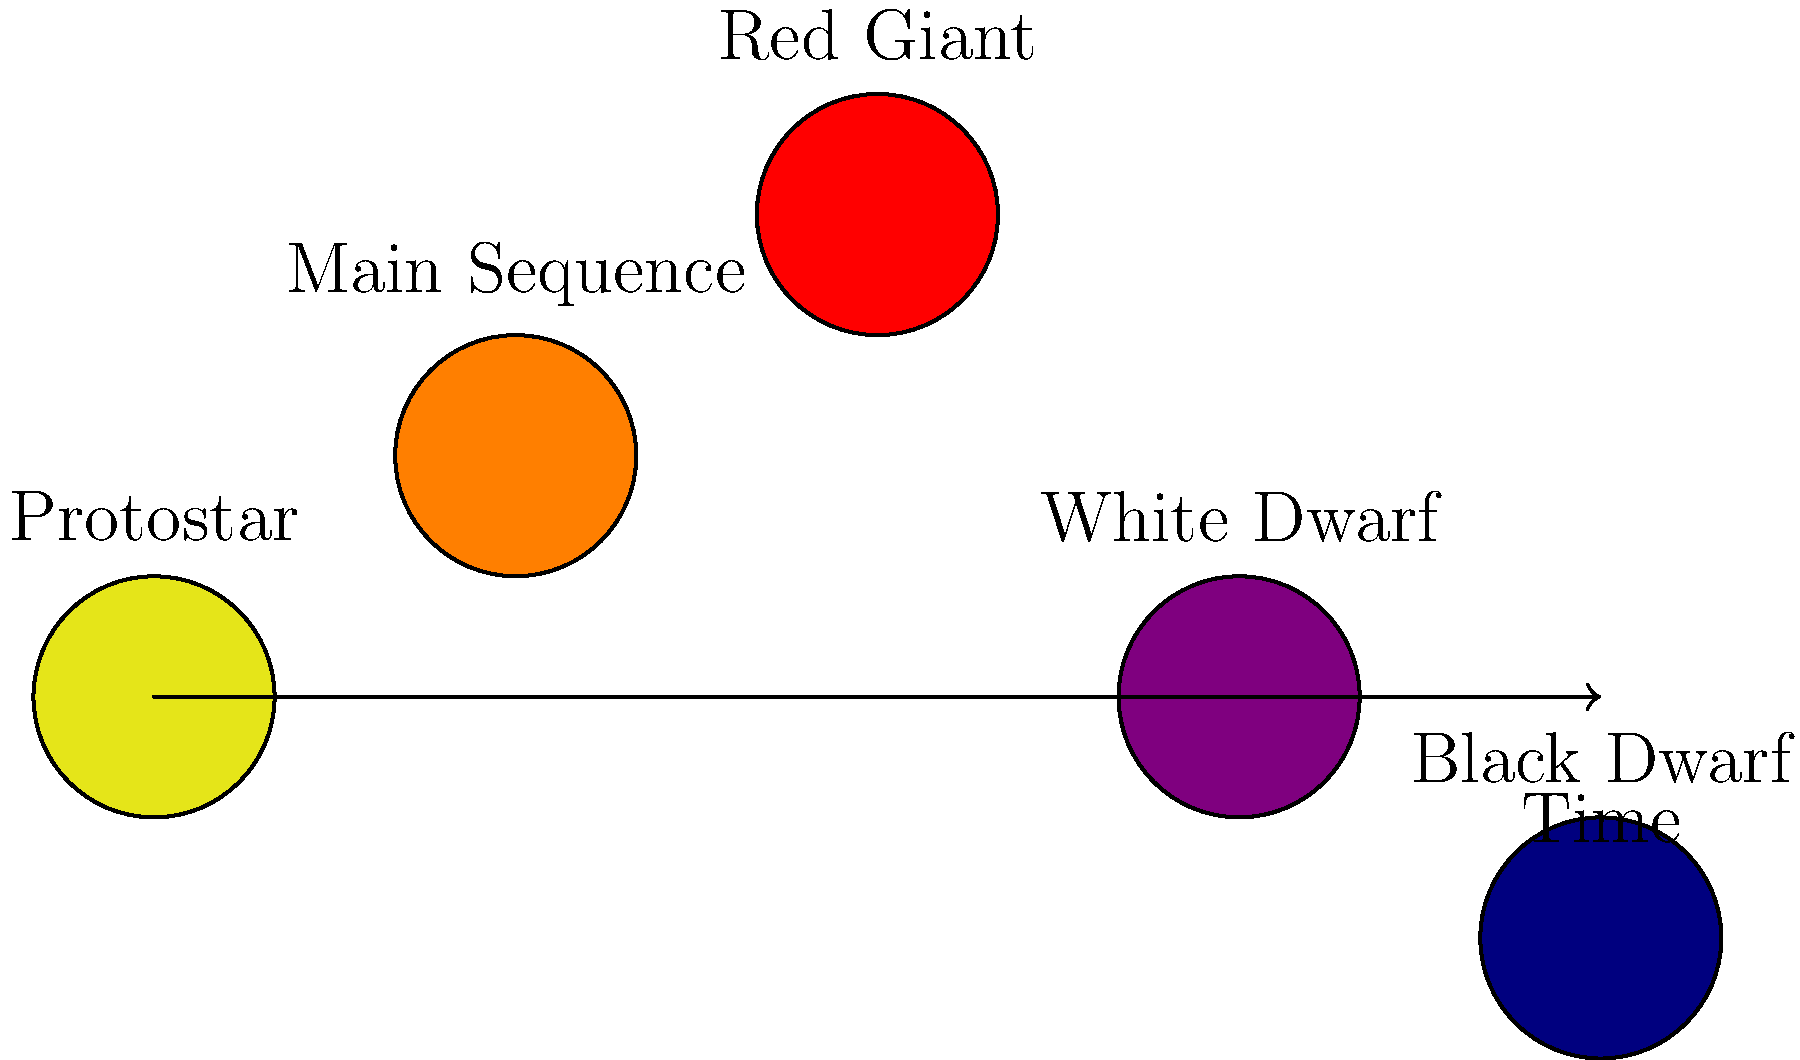As a journalist covering a space science conference, you encounter a diagram depicting the life cycle of a star. Which stage in this cycle represents the longest period in a star's life, and why is this stage crucial for the existence of life as we know it? Let's break down the life cycle of a star and analyze each stage:

1. Protostar: This is the initial stage where a cloud of gas and dust collapses under gravity.

2. Main Sequence: This is the longest stage in a star's life. Here's why it's important:
   a) Duration: It lasts for about 90% of a star's lifetime.
   b) Stability: The star maintains a balance between gravity and outward pressure from nuclear fusion.
   c) Energy Production: Hydrogen is fused into helium in the core, releasing energy.
   d) Importance for Life: This stable period allows for the potential development of life on orbiting planets.

3. Red Giant: As hydrogen in the core is depleted, the star expands and cools.

4. White Dwarf: After shedding its outer layers, the star's core remains as a hot, dense remnant.

5. Black Dwarf: The theoretical final stage where a white dwarf cools completely (hasn't occurred yet in our universe).

The Main Sequence stage is crucial for life because:
- It provides consistent energy output over billions of years.
- This stability allows for the formation and evolution of complex molecules on planets.
- For stars like our Sun, the habitable zone remains relatively constant during this period.
Answer: Main Sequence; provides stable energy output for billions of years, allowing potential life development on orbiting planets. 